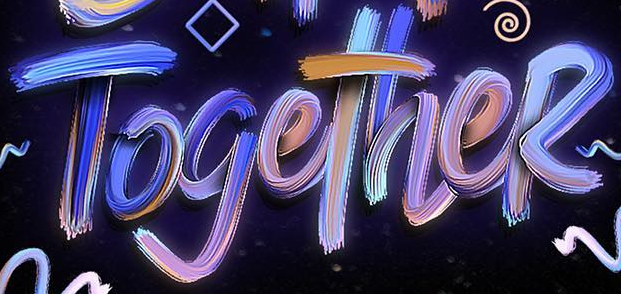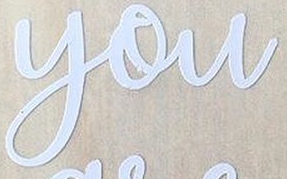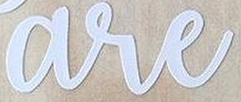Read the text from these images in sequence, separated by a semicolon. TogetheR; you; are 